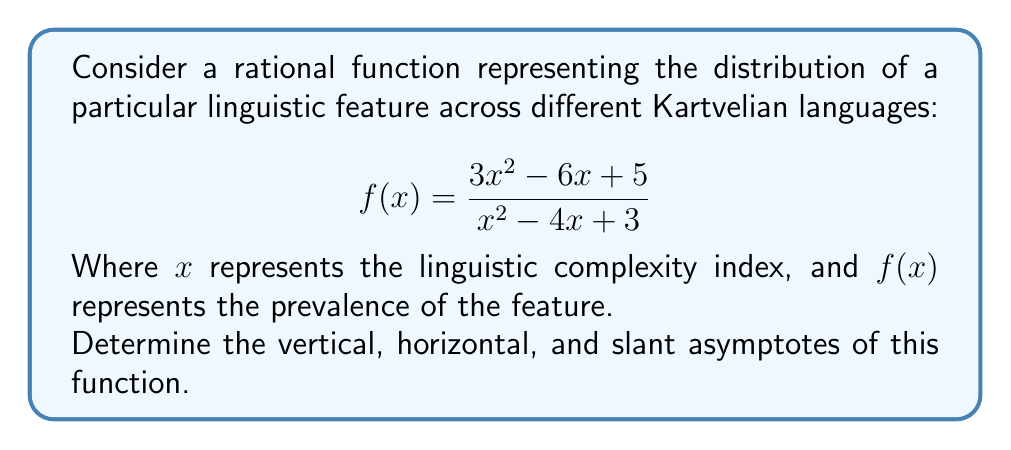Solve this math problem. To find the asymptotes of the rational function, we'll follow these steps:

1. Vertical asymptotes:
   Find values of x where the denominator equals zero.
   $$x^2 - 4x + 3 = 0$$
   $$(x - 1)(x - 3) = 0$$
   $x = 1$ or $x = 3$

2. Horizontal asymptote:
   Compare the degrees of the numerator and denominator.
   Both have degree 2, so we divide the leading coefficients:
   $$\lim_{x \to \infty} \frac{3x^2}{x^2} = 3$$

3. Slant asymptote:
   Since the degrees are equal, there is no slant asymptote.

4. To verify the horizontal asymptote, perform long division:
   $$\frac{3x^2 - 6x + 5}{x^2 - 4x + 3} = 3 + \frac{6x - 4}{x^2 - 4x + 3}$$
   As $x \to \infty$, the fraction approaches 0, confirming the horizontal asymptote.
Answer: Vertical asymptotes: $x = 1$ and $x = 3$; Horizontal asymptote: $y = 3$; No slant asymptote. 